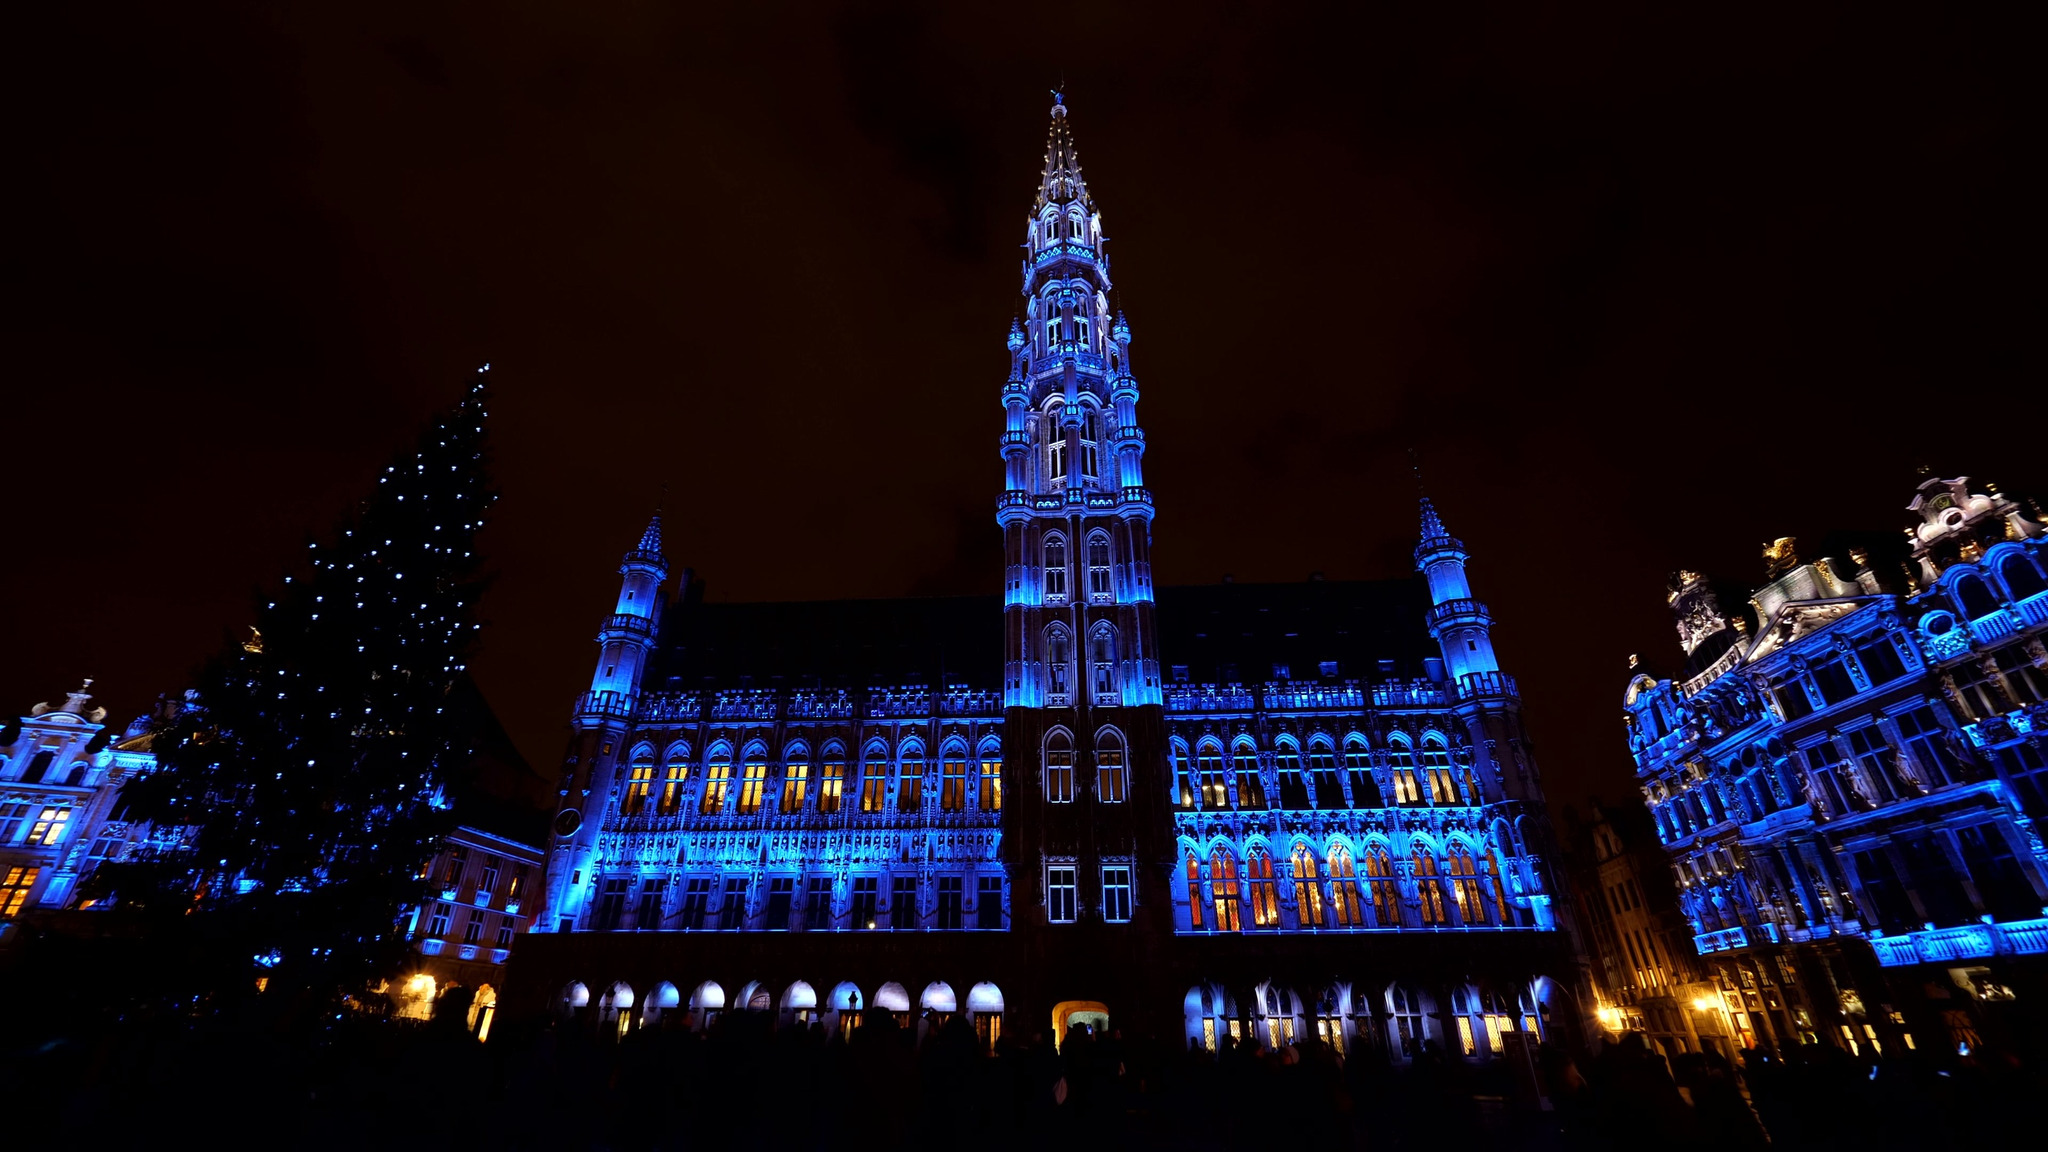Describe the following image. The image showcases the magnificent Brussels Town Hall, an iconic example of Gothic architecture situated in the Grand Place, the central square of Brussels, Belgium. The Town Hall stands resplendent, bathed in striking blue and orange lights that highlight its elaborate façade and pointed spire, contrasting sharply against the dark night sky. On the left side of the frame, a large Christmas tree adorned with glittering lights brings a festive and joyous element to the scene. Surrounding the Town Hall are other richly decorated buildings, all contributing to the grandeur of this historic and picturesque locale. The perspective hints at a panoramic view, likely capturing the entirety of the grand square, enveloping the viewers in the vibrant, celebratory atmosphere of the Grand Place during the holiday season. The code 'sa_15286' might indicate a specific viewpoint or event related to this photographic moment. 